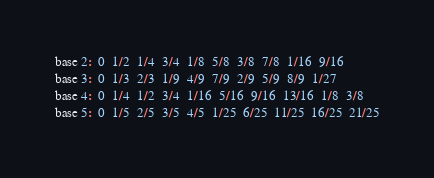Convert code to text. <code><loc_0><loc_0><loc_500><loc_500><_C_>base 2:  0  1/2  1/4  3/4  1/8  5/8  3/8  7/8  1/16  9/16
base 3:  0  1/3  2/3  1/9  4/9  7/9  2/9  5/9  8/9  1/27
base 4:  0  1/4  1/2  3/4  1/16  5/16  9/16  13/16  1/8  3/8
base 5:  0  1/5  2/5  3/5  4/5  1/25  6/25  11/25  16/25  21/25
</code> 